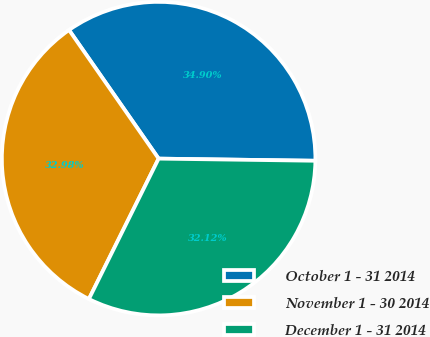Convert chart. <chart><loc_0><loc_0><loc_500><loc_500><pie_chart><fcel>October 1 - 31 2014<fcel>November 1 - 30 2014<fcel>December 1 - 31 2014<nl><fcel>34.9%<fcel>32.98%<fcel>32.12%<nl></chart> 